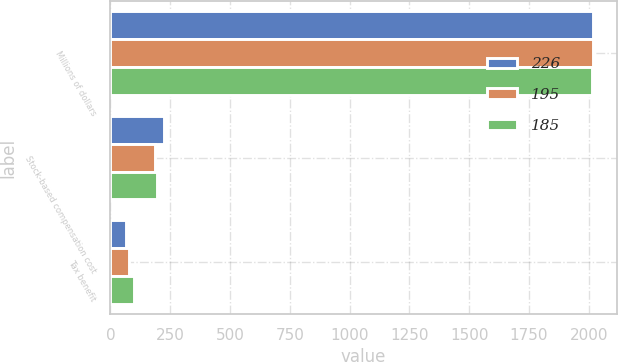Convert chart. <chart><loc_0><loc_0><loc_500><loc_500><stacked_bar_chart><ecel><fcel>Millions of dollars<fcel>Stock-based compensation cost<fcel>Tax benefit<nl><fcel>226<fcel>2017<fcel>226<fcel>64<nl><fcel>195<fcel>2016<fcel>185<fcel>77<nl><fcel>185<fcel>2015<fcel>195<fcel>99<nl></chart> 